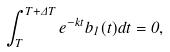Convert formula to latex. <formula><loc_0><loc_0><loc_500><loc_500>\int _ { T } ^ { T + \Delta T } e ^ { - k t } b _ { 1 } ( t ) d t = 0 ,</formula> 